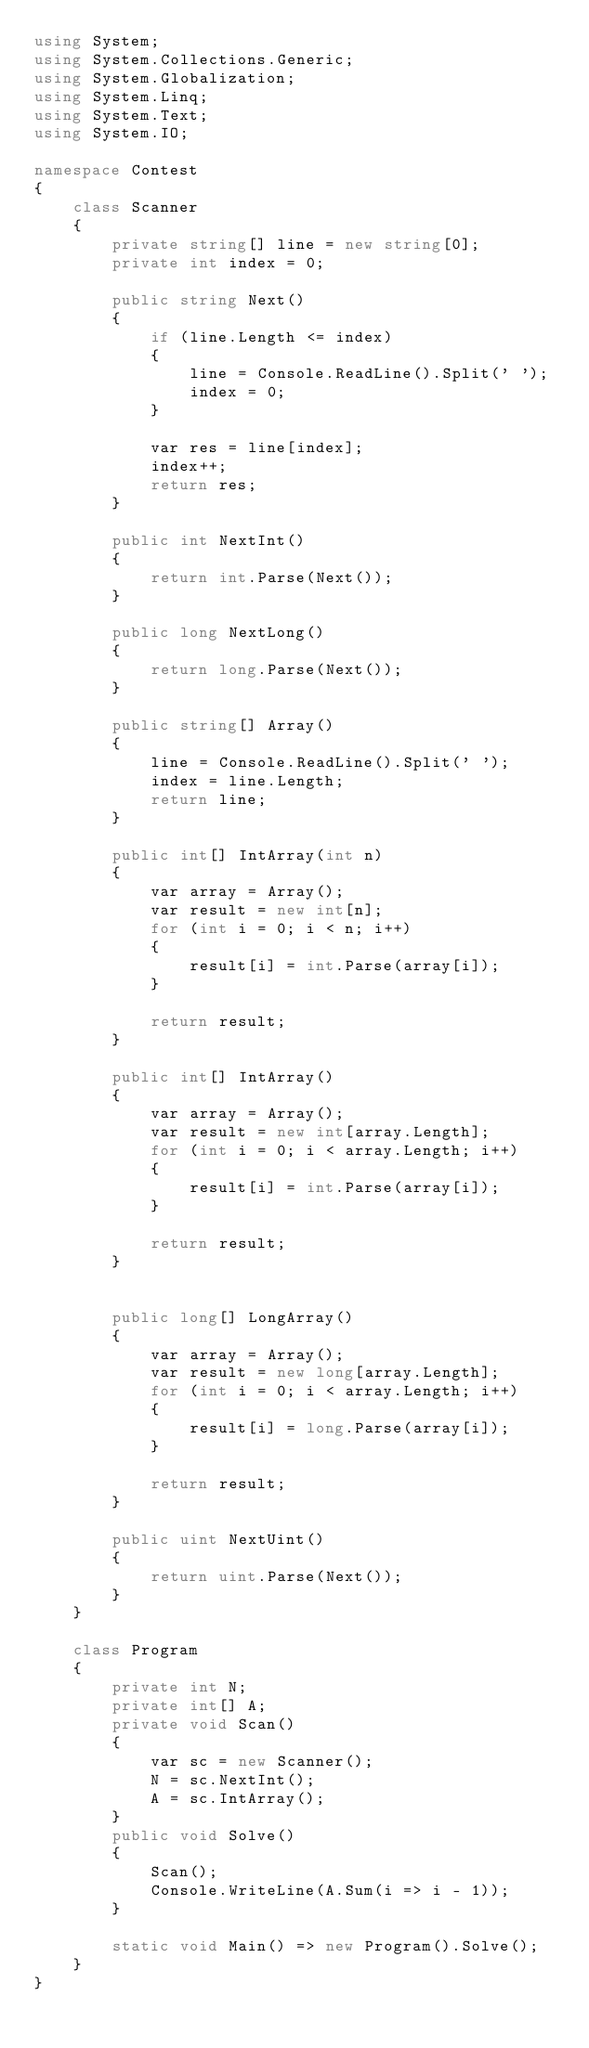<code> <loc_0><loc_0><loc_500><loc_500><_C#_>using System;
using System.Collections.Generic;
using System.Globalization;
using System.Linq;
using System.Text;
using System.IO;

namespace Contest
{
    class Scanner
    {
        private string[] line = new string[0];
        private int index = 0;

        public string Next()
        {
            if (line.Length <= index)
            {
                line = Console.ReadLine().Split(' ');
                index = 0;
            }

            var res = line[index];
            index++;
            return res;
        }

        public int NextInt()
        {
            return int.Parse(Next());
        }

        public long NextLong()
        {
            return long.Parse(Next());
        }

        public string[] Array()
        {
            line = Console.ReadLine().Split(' ');
            index = line.Length;
            return line;
        }

        public int[] IntArray(int n)
        {
            var array = Array();
            var result = new int[n];
            for (int i = 0; i < n; i++)
            {
                result[i] = int.Parse(array[i]);
            }

            return result;
        }

        public int[] IntArray()
        {
            var array = Array();
            var result = new int[array.Length];
            for (int i = 0; i < array.Length; i++)
            {
                result[i] = int.Parse(array[i]);
            }

            return result;
        }


        public long[] LongArray()
        {
            var array = Array();
            var result = new long[array.Length];
            for (int i = 0; i < array.Length; i++)
            {
                result[i] = long.Parse(array[i]);
            }

            return result;
        }

        public uint NextUint()
        {
            return uint.Parse(Next());
        }
    }

    class Program
    {
        private int N;
        private int[] A;
        private void Scan()
        {
            var sc = new Scanner();
            N = sc.NextInt();
            A = sc.IntArray();
        }
        public void Solve()
        {
            Scan();
            Console.WriteLine(A.Sum(i => i - 1));
        }

        static void Main() => new Program().Solve();
    }
}</code> 